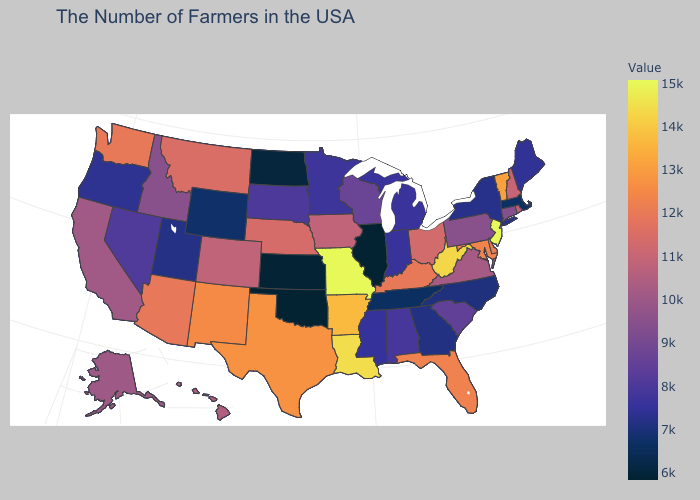Does the map have missing data?
Be succinct. No. Which states hav the highest value in the Northeast?
Answer briefly. New Jersey. Does the map have missing data?
Quick response, please. No. Which states have the lowest value in the USA?
Give a very brief answer. Illinois. Which states have the lowest value in the USA?
Be succinct. Illinois. 